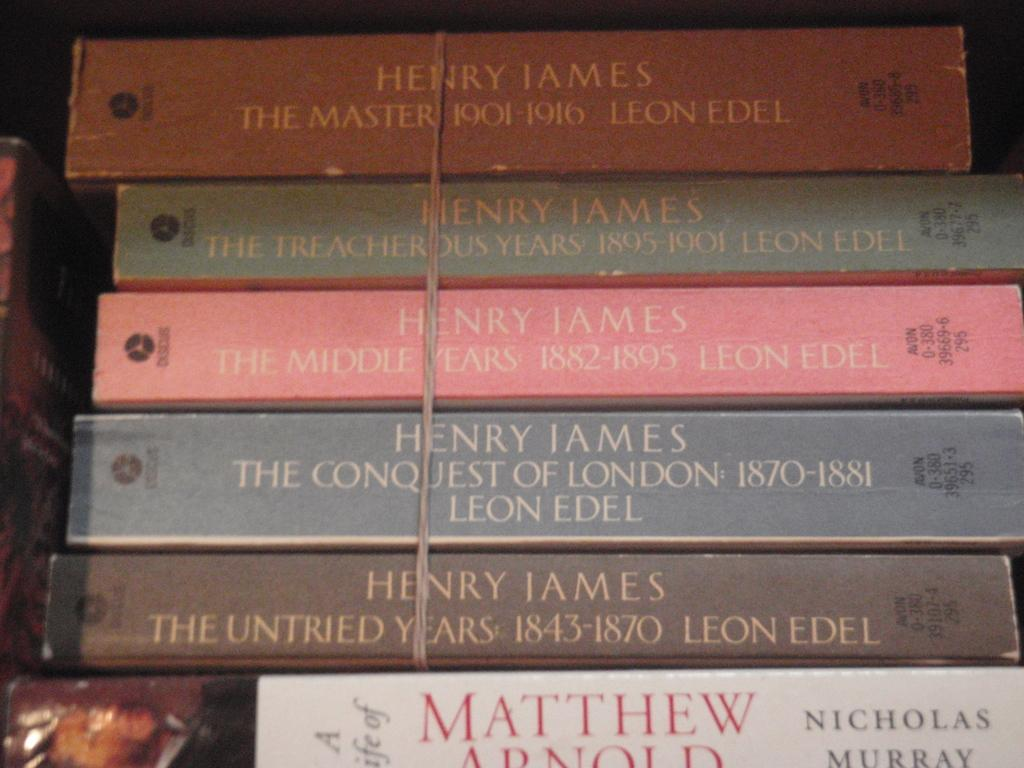<image>
Summarize the visual content of the image. Several books about Henry James are stacked together. 